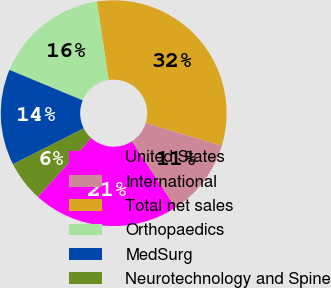Convert chart to OTSL. <chart><loc_0><loc_0><loc_500><loc_500><pie_chart><fcel>United States<fcel>International<fcel>Total net sales<fcel>Orthopaedics<fcel>MedSurg<fcel>Neurotechnology and Spine<nl><fcel>20.95%<fcel>11.1%<fcel>32.05%<fcel>16.35%<fcel>13.73%<fcel>5.81%<nl></chart> 